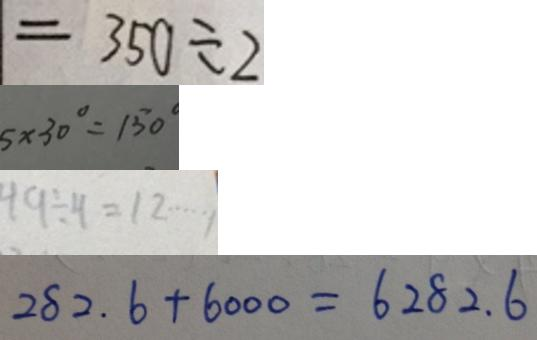Convert formula to latex. <formula><loc_0><loc_0><loc_500><loc_500>= 3 5 0 \div 2 
 5 \times 3 0 ^ { \circ } = 1 5 0 ^ { \circ } 
 4 9 \div 4 = 1 2 \cdots 1 
 2 8 2 . 6 + 6 0 0 0 = 6 2 8 2 . 6</formula> 